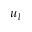Convert formula to latex. <formula><loc_0><loc_0><loc_500><loc_500>u _ { l }</formula> 